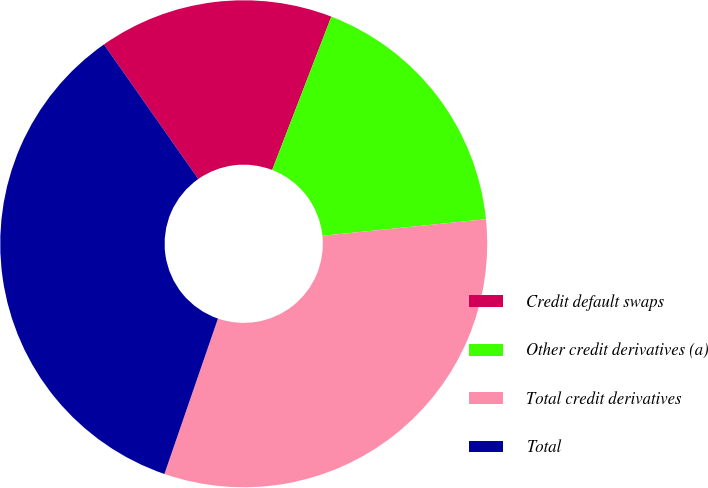<chart> <loc_0><loc_0><loc_500><loc_500><pie_chart><fcel>Credit default swaps<fcel>Other credit derivatives (a)<fcel>Total credit derivatives<fcel>Total<nl><fcel>15.59%<fcel>17.53%<fcel>31.89%<fcel>34.99%<nl></chart> 